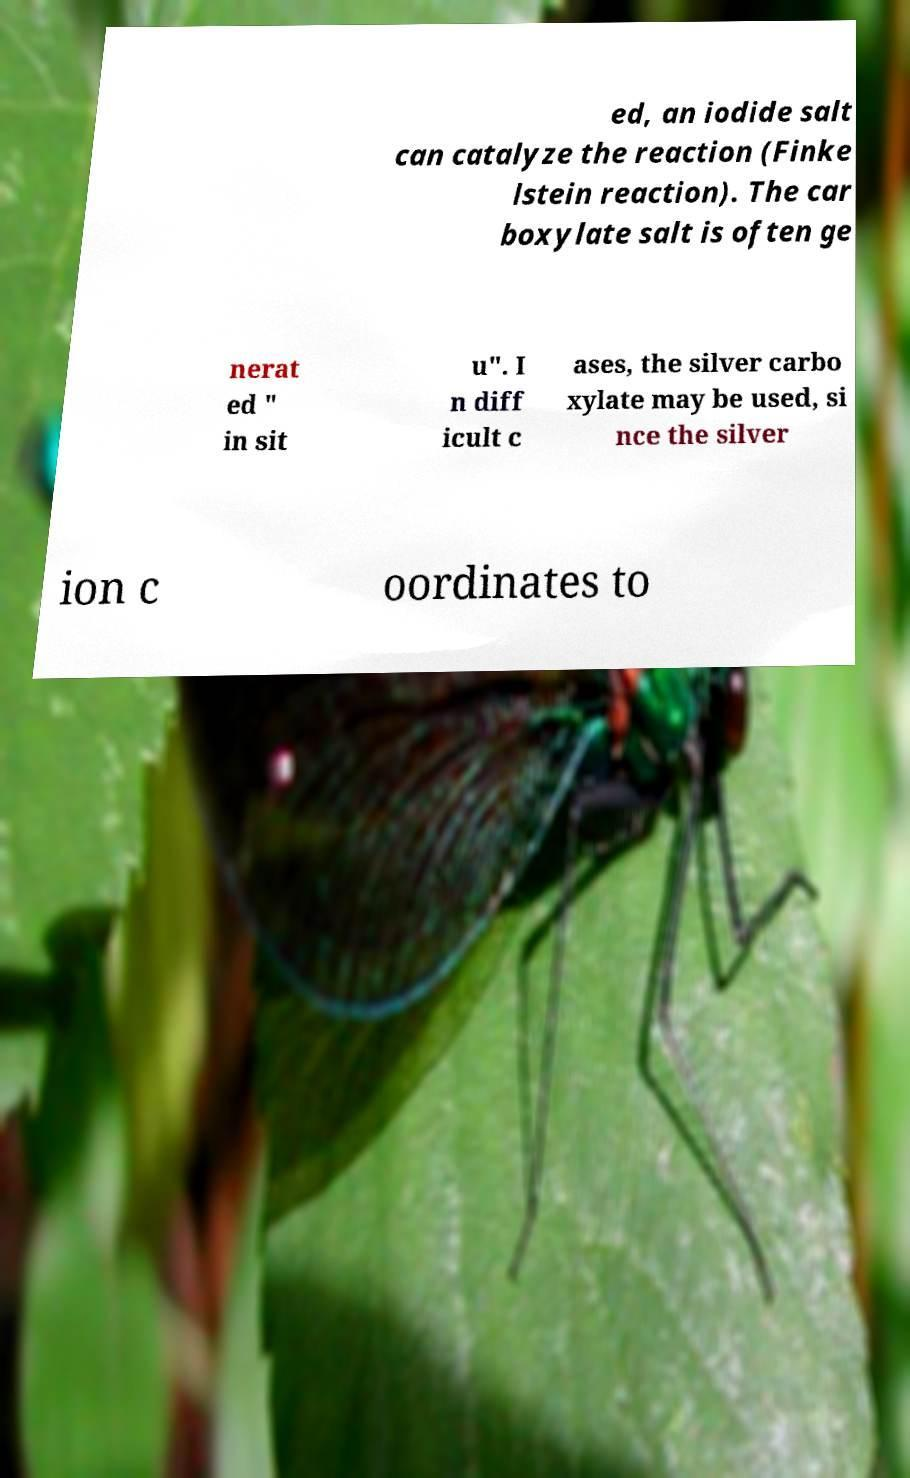Please read and relay the text visible in this image. What does it say? ed, an iodide salt can catalyze the reaction (Finke lstein reaction). The car boxylate salt is often ge nerat ed " in sit u". I n diff icult c ases, the silver carbo xylate may be used, si nce the silver ion c oordinates to 